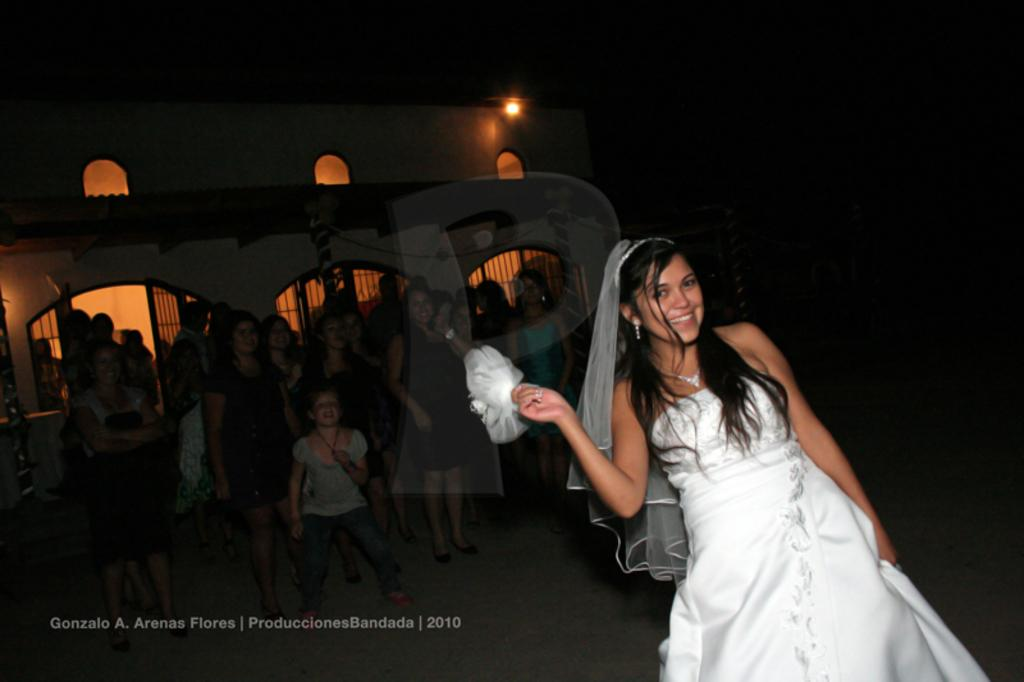What is the main subject of the image? There is a girl standing in the image. Can you describe the surroundings of the girl? There are people standing in the background of the image, and there is a building visible in the background as well. Is there any text present in the image? Yes, there is text in the bottom left corner of the image. What type of seed is being planted in the scene? There is no scene of planting seeds in the image; it features a girl standing with people and a building in the background. What kind of noise can be heard coming from the image? There is no sound or noise present in the image, as it is a still photograph. 